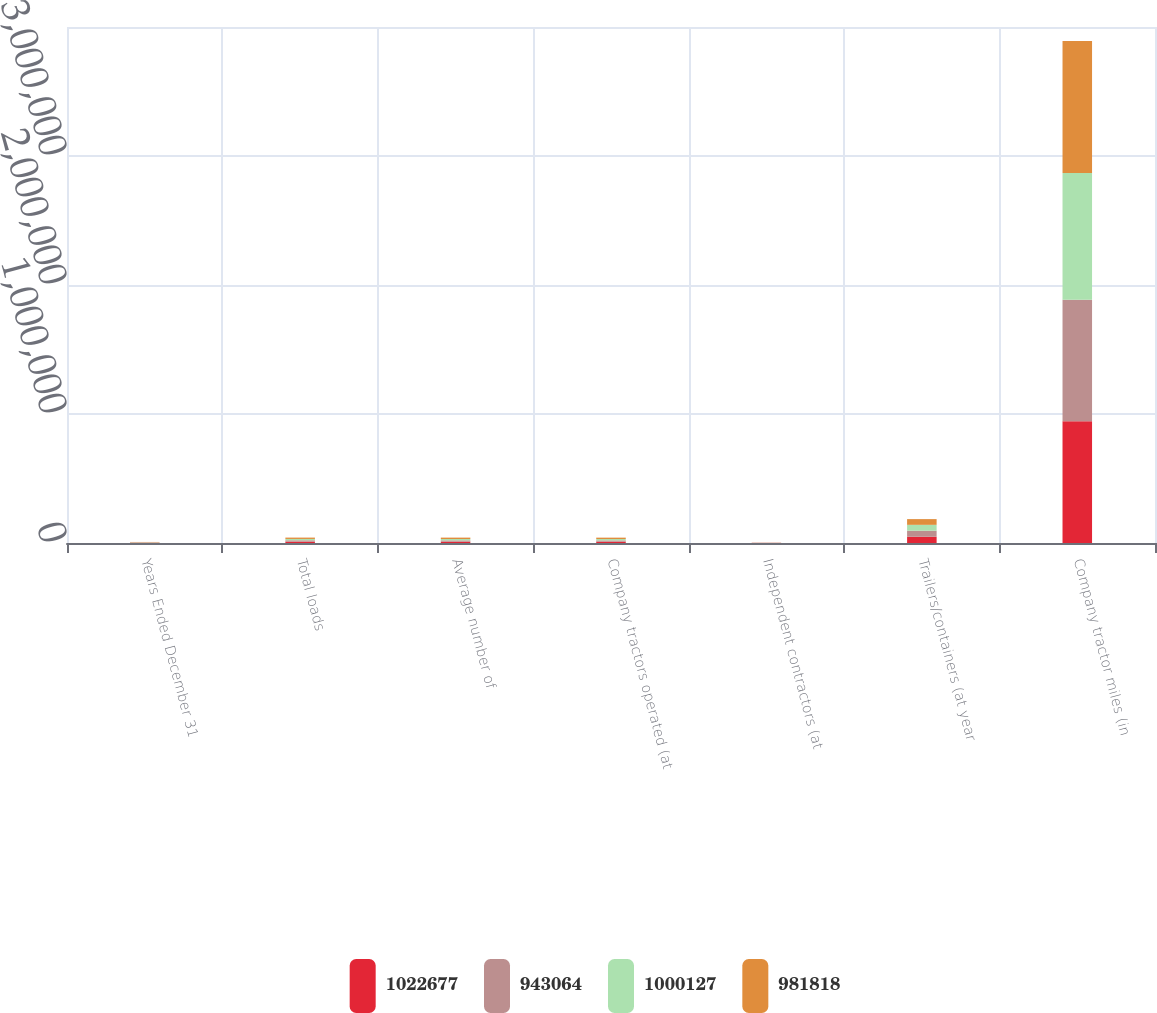Convert chart. <chart><loc_0><loc_0><loc_500><loc_500><stacked_bar_chart><ecel><fcel>Years Ended December 31<fcel>Total loads<fcel>Average number of<fcel>Company tractors operated (at<fcel>Independent contractors (at<fcel>Trailers/containers (at year<fcel>Company tractor miles (in<nl><fcel>1.02268e+06<fcel>2004<fcel>10473<fcel>10042<fcel>10151<fcel>1301<fcel>48317<fcel>943064<nl><fcel>943064<fcel>2003<fcel>10473<fcel>10293<fcel>9932<fcel>994<fcel>46747<fcel>943054<nl><fcel>1.00013e+06<fcel>2002<fcel>10473<fcel>10712<fcel>10653<fcel>679<fcel>45759<fcel>981818<nl><fcel>981818<fcel>2001<fcel>10473<fcel>10710<fcel>10770<fcel>336<fcel>44318<fcel>1.02268e+06<nl></chart> 